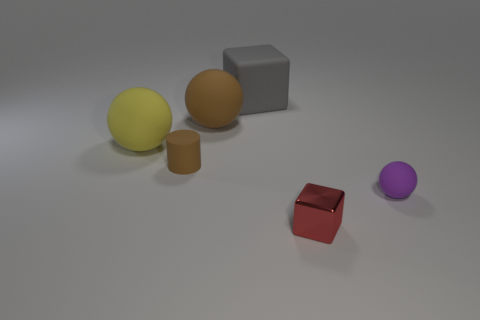Are there any other things that have the same material as the tiny red object?
Provide a succinct answer. No. There is a cylinder that is the same size as the red shiny cube; what is its color?
Make the answer very short. Brown. The purple object is what size?
Your answer should be very brief. Small. Are the thing that is on the right side of the red metal cube and the tiny block made of the same material?
Provide a succinct answer. No. Is the tiny brown object the same shape as the purple thing?
Your answer should be compact. No. There is a thing in front of the tiny matte thing that is right of the red metal object in front of the yellow thing; what is its shape?
Make the answer very short. Cube. There is a small rubber object that is behind the small purple object; does it have the same shape as the tiny rubber thing that is right of the gray thing?
Your answer should be very brief. No. Is there a large yellow ball made of the same material as the tiny cube?
Offer a terse response. No. What color is the large matte ball that is in front of the rubber ball that is behind the large sphere that is in front of the big brown thing?
Keep it short and to the point. Yellow. Is the small object to the left of the big gray rubber thing made of the same material as the tiny cube on the right side of the gray rubber object?
Make the answer very short. No. 